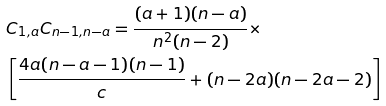<formula> <loc_0><loc_0><loc_500><loc_500>& C _ { 1 , a } C _ { n - 1 , n - a } = \frac { ( a + 1 ) ( n - a ) } { n ^ { 2 } ( n - 2 ) } \times \\ & \left [ \frac { 4 a ( n - a - 1 ) ( n - 1 ) } { c } + ( n - 2 a ) ( n - 2 a - 2 ) \right ]</formula> 